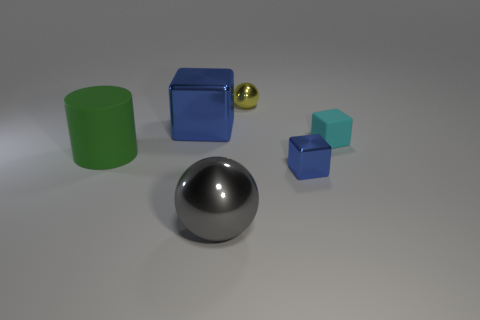Add 3 green matte cylinders. How many objects exist? 9 Subtract all spheres. How many objects are left? 4 Subtract all gray rubber cylinders. Subtract all blue cubes. How many objects are left? 4 Add 3 tiny objects. How many tiny objects are left? 6 Add 1 large metallic blocks. How many large metallic blocks exist? 2 Subtract 0 purple cylinders. How many objects are left? 6 